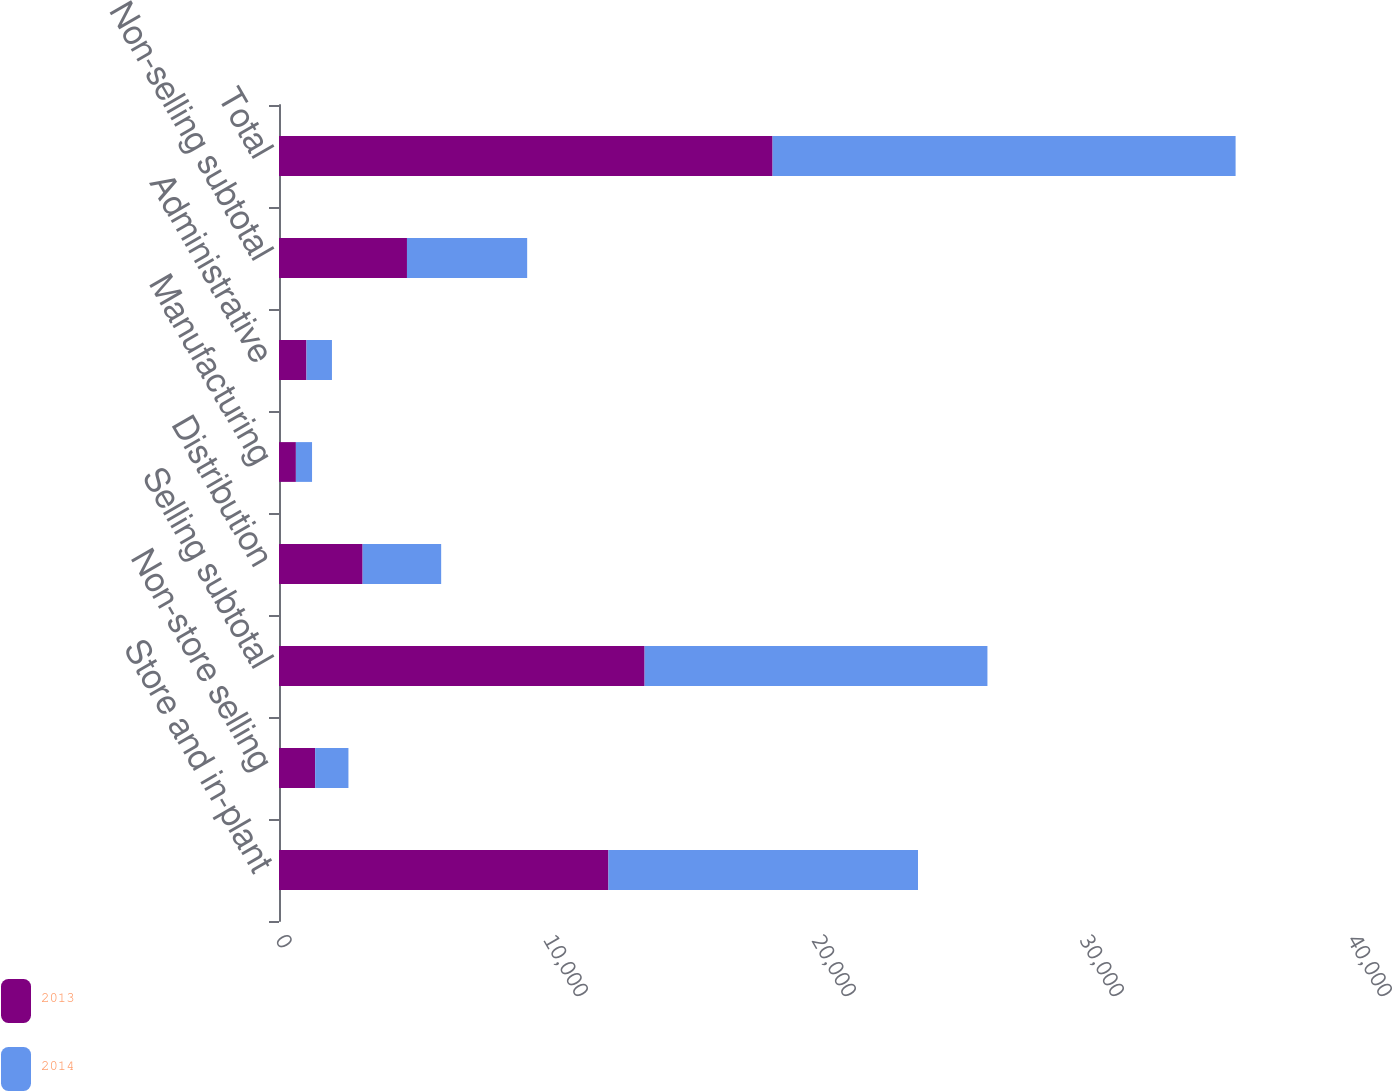<chart> <loc_0><loc_0><loc_500><loc_500><stacked_bar_chart><ecel><fcel>Store and in-plant<fcel>Non-store selling<fcel>Selling subtotal<fcel>Distribution<fcel>Manufacturing<fcel>Administrative<fcel>Non-selling subtotal<fcel>Total<nl><fcel>2013<fcel>12293<fcel>1349<fcel>13642<fcel>3120<fcel>630<fcel>1025<fcel>4775<fcel>18417<nl><fcel>2014<fcel>11550<fcel>1242<fcel>12792<fcel>2931<fcel>603<fcel>951<fcel>4485<fcel>17277<nl></chart> 